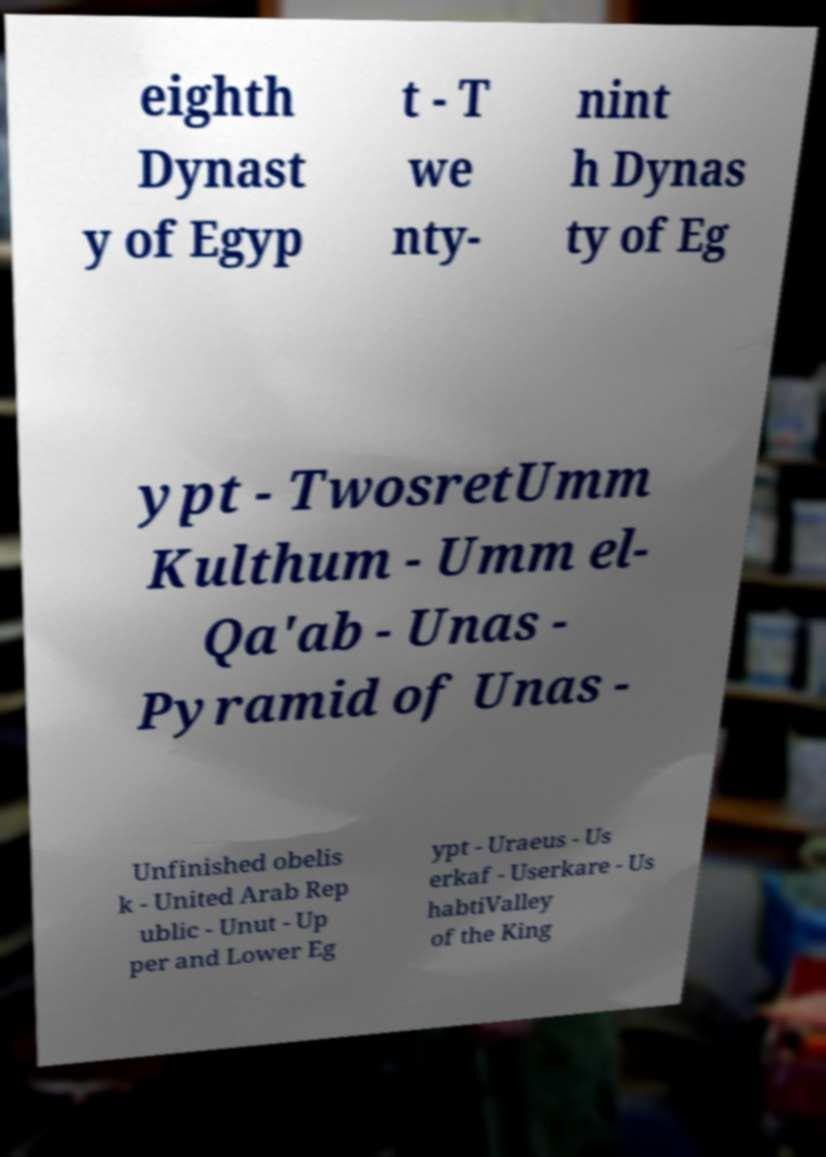Please identify and transcribe the text found in this image. eighth Dynast y of Egyp t - T we nty- nint h Dynas ty of Eg ypt - TwosretUmm Kulthum - Umm el- Qa'ab - Unas - Pyramid of Unas - Unfinished obelis k - United Arab Rep ublic - Unut - Up per and Lower Eg ypt - Uraeus - Us erkaf - Userkare - Us habtiValley of the King 